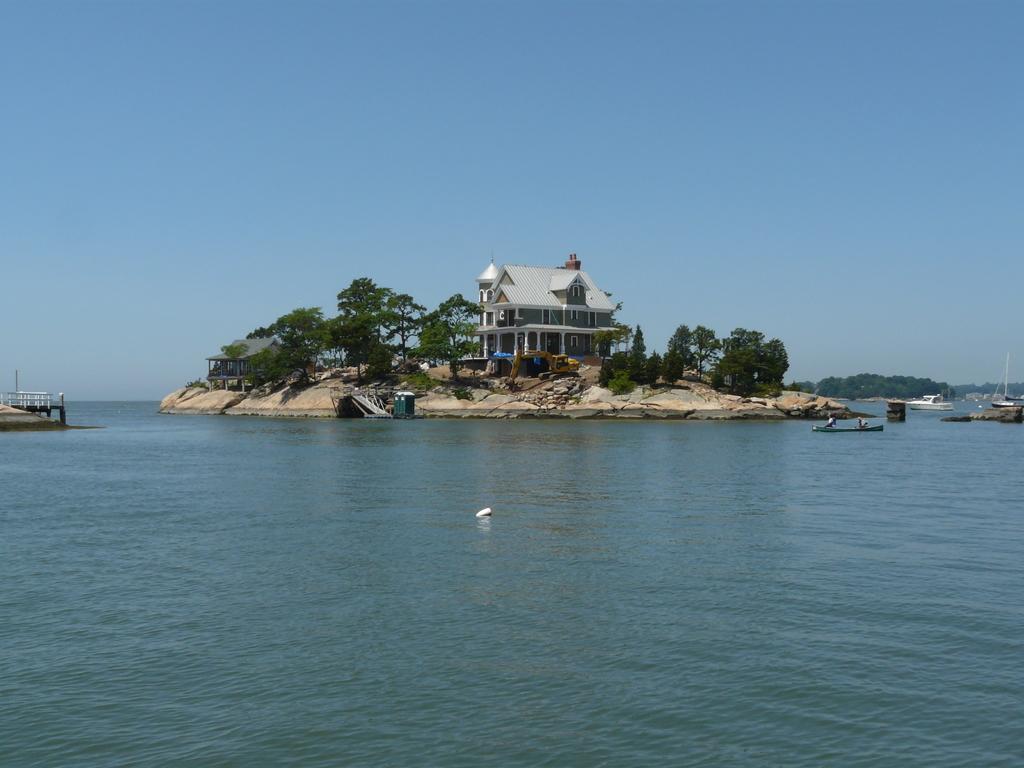Can you describe this image briefly? This image is taken outdoors. At the top of the image there is the sky. At the bottom of the image there is a sea with water. On the left side of the image there is a railing. There is a sea shore. In the background there are a few trees. On the right side of the image there are a few boats on the sea. In the middle of the image there is a ground. There are a few trees and plants on the ground. There are two houses and a building with walls, windows, doors and roofs. 